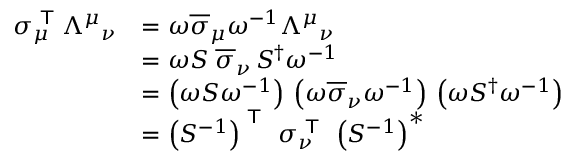<formula> <loc_0><loc_0><loc_500><loc_500>{ \begin{array} { r l } { \sigma _ { \mu } ^ { T } { \Lambda ^ { \mu } } _ { \nu } } & { = \omega { \overline { \sigma } } _ { \mu } \omega ^ { - 1 } { \Lambda ^ { \mu } } _ { \nu } } \\ & { = \omega S \, { \overline { \sigma } } _ { \nu } \, S ^ { \dagger } \omega ^ { - 1 } } \\ & { = \left ( \omega S \omega ^ { - 1 } \right ) \, \left ( \omega { \overline { \sigma } } _ { \nu } \omega ^ { - 1 } \right ) \, \left ( \omega S ^ { \dagger } \omega ^ { - 1 } \right ) } \\ & { = \left ( S ^ { - 1 } \right ) ^ { T } \, \sigma _ { \nu } ^ { T } \, \left ( S ^ { - 1 } \right ) ^ { * } } \end{array} }</formula> 